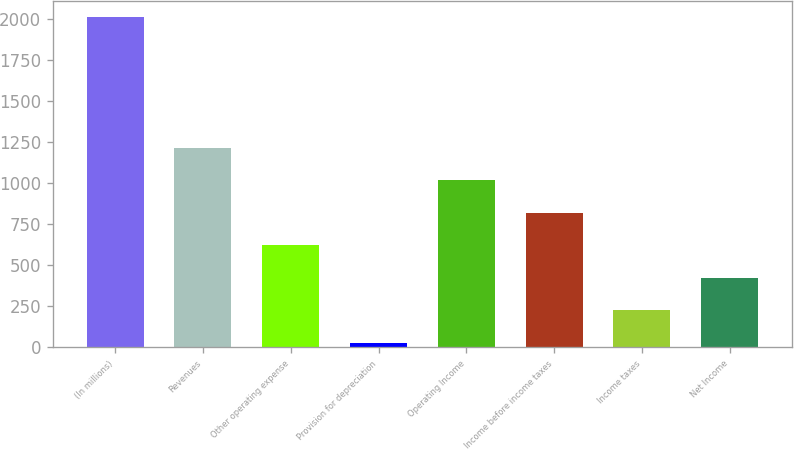Convert chart to OTSL. <chart><loc_0><loc_0><loc_500><loc_500><bar_chart><fcel>(In millions)<fcel>Revenues<fcel>Other operating expense<fcel>Provision for depreciation<fcel>Operating Income<fcel>Income before income taxes<fcel>Income taxes<fcel>Net Income<nl><fcel>2010<fcel>1216.8<fcel>621.9<fcel>27<fcel>1018.5<fcel>820.2<fcel>225.3<fcel>423.6<nl></chart> 